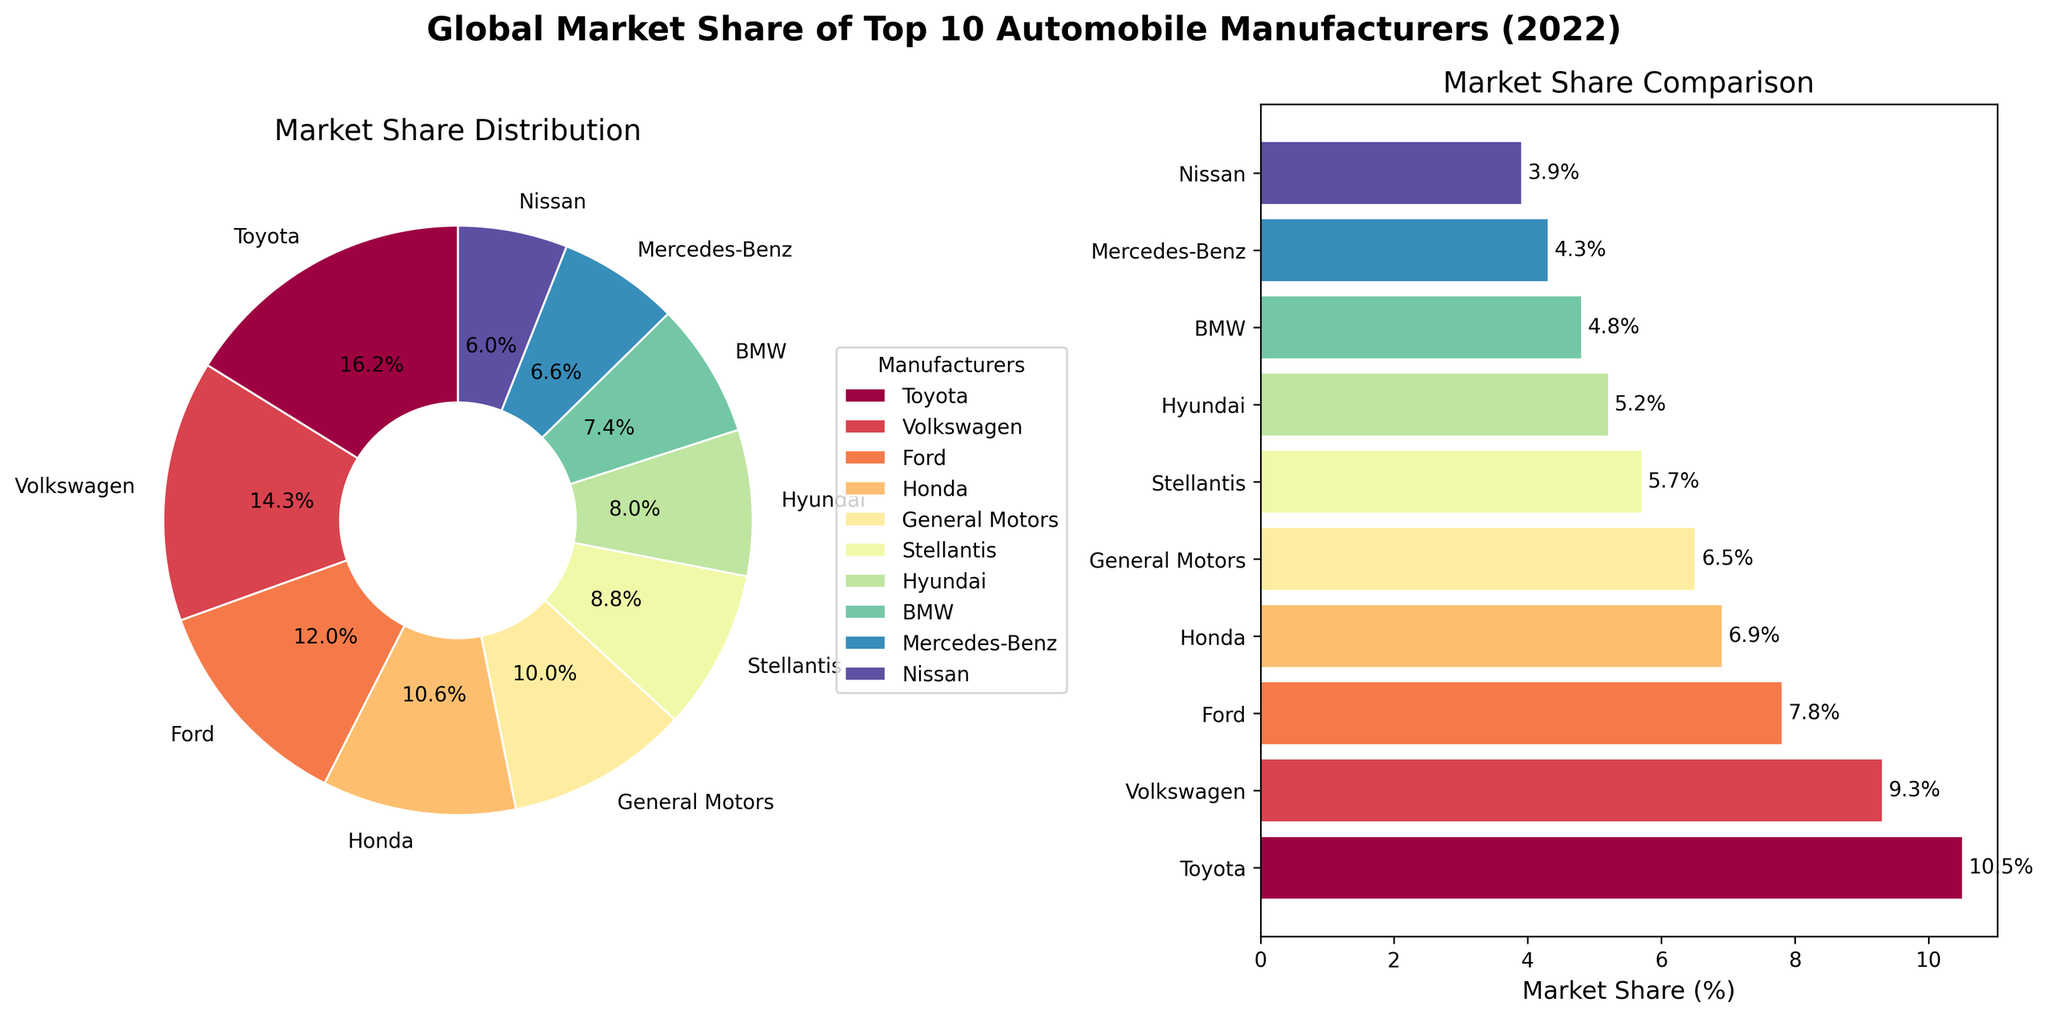What's the title of the figure? The title is displayed at the top center of the figure in bold font, and it reads "Global Market Share of Top 10 Automobile Manufacturers (2022)".
Answer: Global Market Share of Top 10 Automobile Manufacturers (2022) How many manufacturers are depicted in the plot? The pie chart and bar chart both label 10 different manufacturers, each with a different color.
Answer: 10 Which manufacturer has the highest market share? By observing the pie chart and bar chart, the segment or bar representing Toyota is the largest, indicating they have the highest market share.
Answer: Toyota What is the market share percentage of Volkswagen? The pie chart segment and the corresponding bar for Volkswagen are labeled with their percentage, which is 9.3%.
Answer: 9.3% How much combined market share do General Motors and Nissan have? Adding the market shares from the bar chart, General Motors has 6.5% and Nissan has 3.9%. Summing these gives 6.5 + 3.9 = 10.4%.
Answer: 10.4% Which two manufacturers have the smallest market shares? The bar chart shows the smallest bars belong to Nissan and Mercedes-Benz, indicating they have the smallest market shares.
Answer: Nissan and Mercedes-Benz How does the market share of Honda compare to Ford? The bar chart shows that Honda has a market share of 6.9%, while Ford has a market share of 7.8%. Thus, Ford's market share is greater than Honda's.
Answer: Ford's market share is greater Which manufacturer sits between General Motors and BMW in market share? Observing the bar chart, Stellantis sits between General Motors and BMW in terms of market share.
Answer: Stellantis What is the total market share of the top three manufacturers? Adding the market shares from the bar chart, the top three manufacturers are Toyota (10.5%), Volkswagen (9.3%), and Ford (7.8%). Summing these gives 10.5 + 9.3 + 7.8 = 27.6%.
Answer: 27.6% Which manufacturer has a market share closest to 5%? The bar chart shows that Hyundai's market share is closest to 5%, at 5.2%.
Answer: Hyundai 